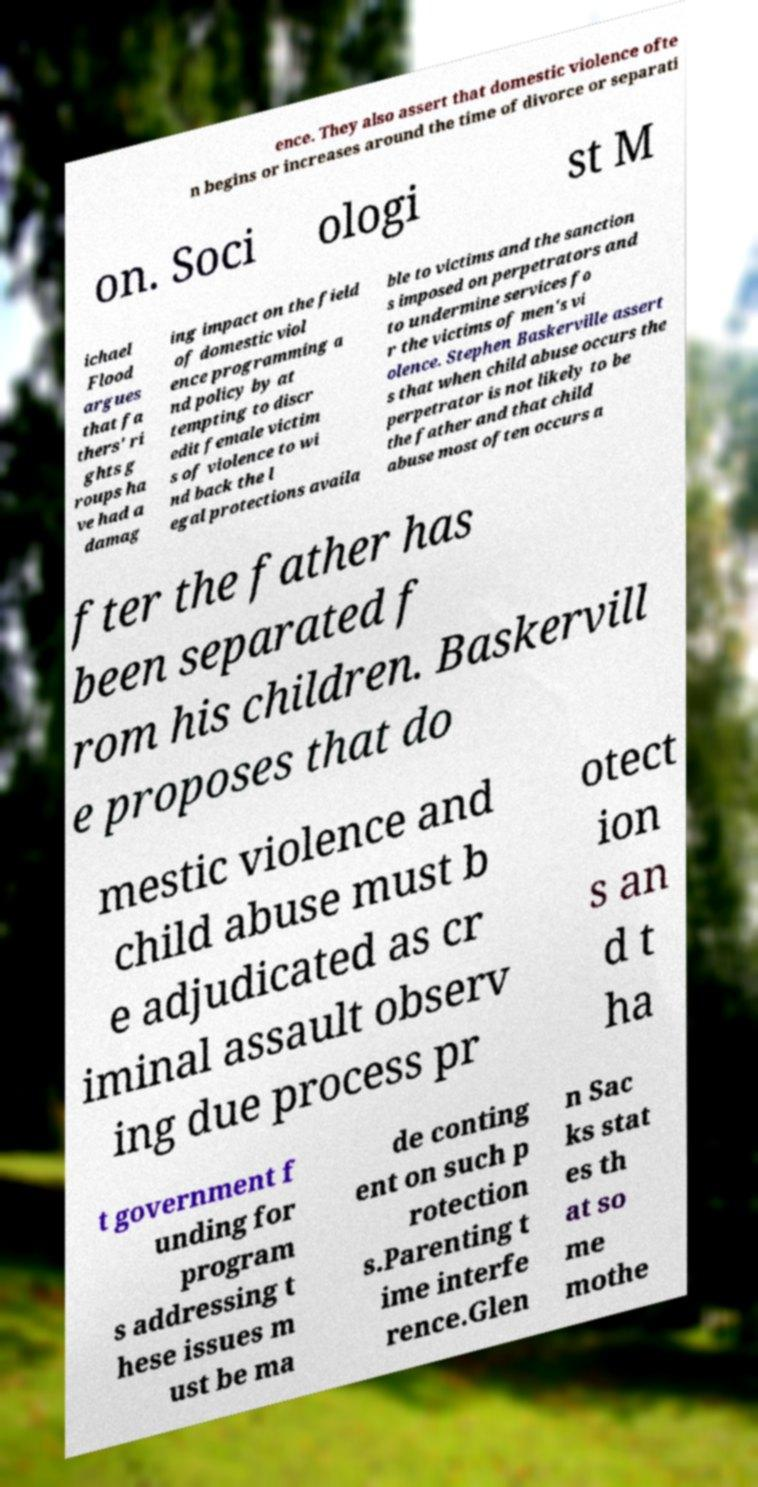There's text embedded in this image that I need extracted. Can you transcribe it verbatim? ence. They also assert that domestic violence ofte n begins or increases around the time of divorce or separati on. Soci ologi st M ichael Flood argues that fa thers' ri ghts g roups ha ve had a damag ing impact on the field of domestic viol ence programming a nd policy by at tempting to discr edit female victim s of violence to wi nd back the l egal protections availa ble to victims and the sanction s imposed on perpetrators and to undermine services fo r the victims of men's vi olence. Stephen Baskerville assert s that when child abuse occurs the perpetrator is not likely to be the father and that child abuse most often occurs a fter the father has been separated f rom his children. Baskervill e proposes that do mestic violence and child abuse must b e adjudicated as cr iminal assault observ ing due process pr otect ion s an d t ha t government f unding for program s addressing t hese issues m ust be ma de conting ent on such p rotection s.Parenting t ime interfe rence.Glen n Sac ks stat es th at so me mothe 